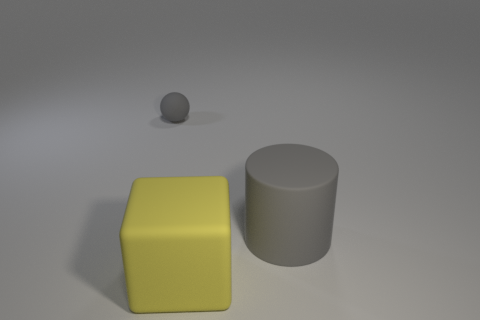Can you tell me about the lighting in the scene? Certainly. The lighting in the scene appears to be coming from the upper left side, creating soft shadows that trail towards the bottom right. This can be observed by the shadows cast by the cube and the cylinder. 